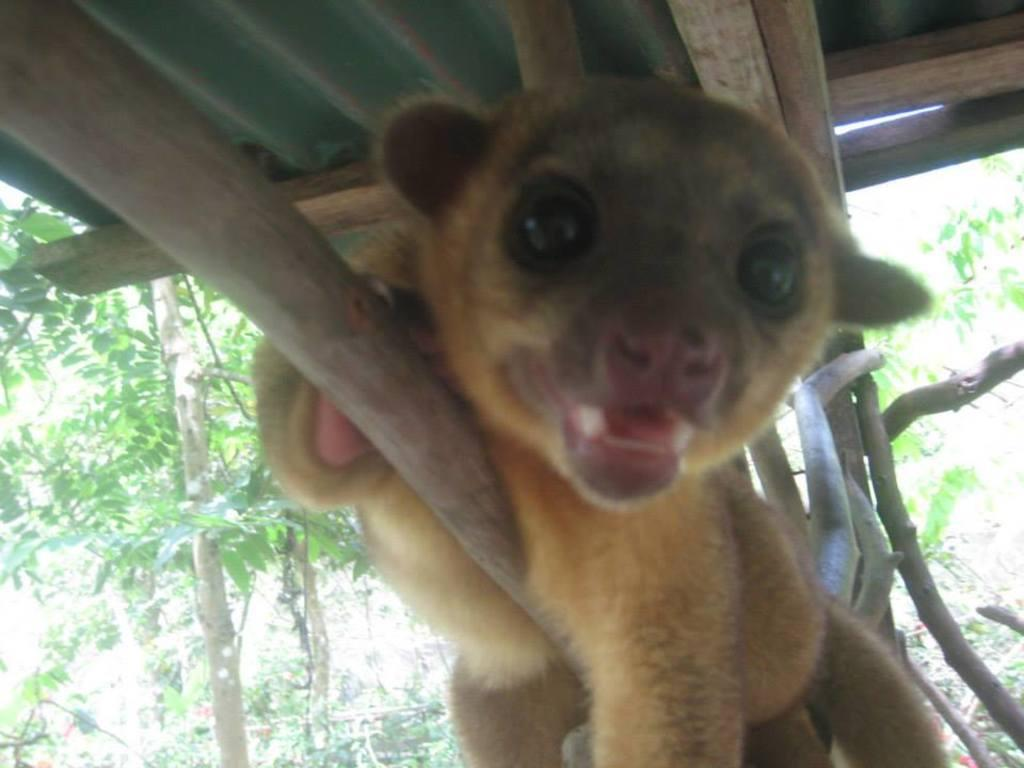What is the main subject in the center of the image? There is an animal in the center of the image. What can be seen in the background of the image? There are trees in the background of the image. What structure is visible at the top of the image? There is a shelter visible at the top of the image. How many goldfish are swimming in the image? There are no goldfish present in the image. What type of gate can be seen in the image? There is no gate present in the image. 